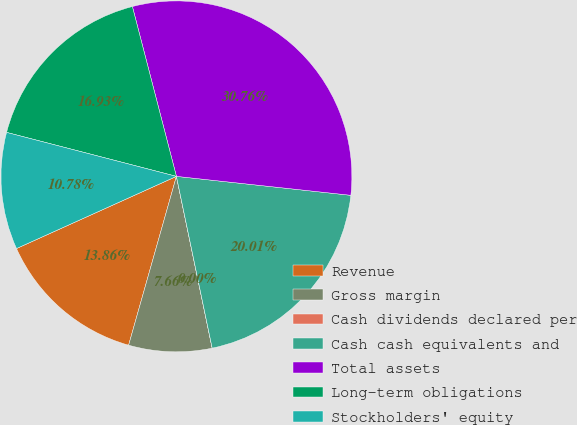<chart> <loc_0><loc_0><loc_500><loc_500><pie_chart><fcel>Revenue<fcel>Gross margin<fcel>Cash dividends declared per<fcel>Cash cash equivalents and<fcel>Total assets<fcel>Long-term obligations<fcel>Stockholders' equity<nl><fcel>13.86%<fcel>7.66%<fcel>0.0%<fcel>20.01%<fcel>30.76%<fcel>16.93%<fcel>10.78%<nl></chart> 